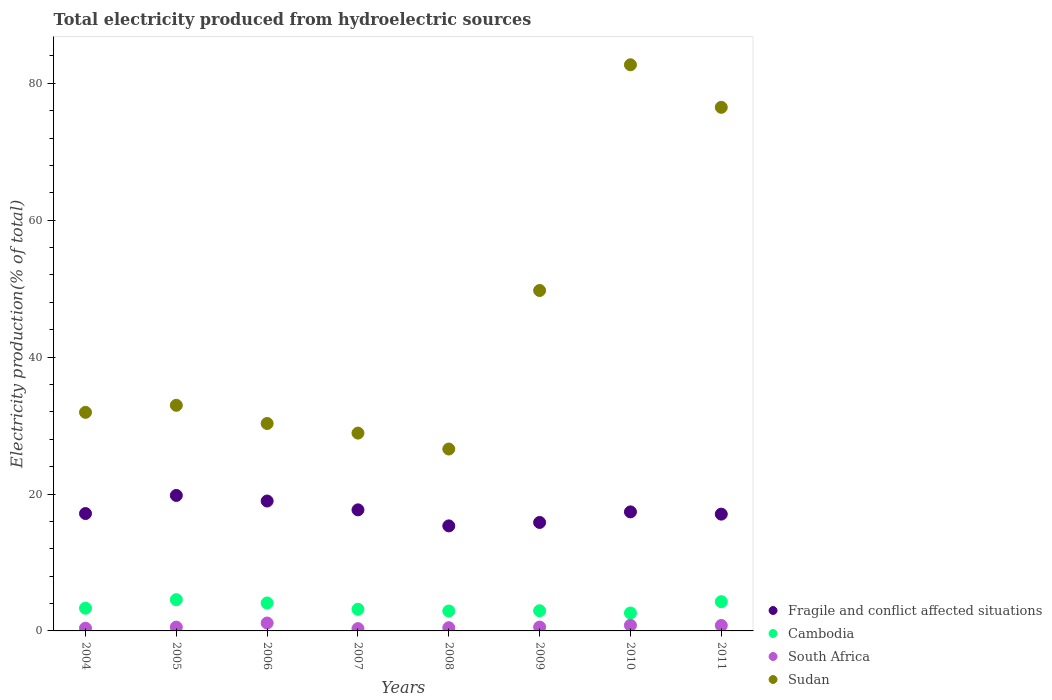What is the total electricity produced in Cambodia in 2005?
Provide a succinct answer. 4.56. Across all years, what is the maximum total electricity produced in Sudan?
Provide a succinct answer. 82.7. Across all years, what is the minimum total electricity produced in Fragile and conflict affected situations?
Your response must be concise. 15.34. In which year was the total electricity produced in Sudan minimum?
Your answer should be very brief. 2008. What is the total total electricity produced in South Africa in the graph?
Offer a very short reply. 5.09. What is the difference between the total electricity produced in Fragile and conflict affected situations in 2004 and that in 2006?
Provide a succinct answer. -1.83. What is the difference between the total electricity produced in Cambodia in 2004 and the total electricity produced in Sudan in 2007?
Offer a very short reply. -25.58. What is the average total electricity produced in South Africa per year?
Make the answer very short. 0.64. In the year 2011, what is the difference between the total electricity produced in Fragile and conflict affected situations and total electricity produced in Sudan?
Ensure brevity in your answer.  -59.43. In how many years, is the total electricity produced in Sudan greater than 60 %?
Ensure brevity in your answer.  2. What is the ratio of the total electricity produced in Cambodia in 2004 to that in 2007?
Your answer should be very brief. 1.05. What is the difference between the highest and the second highest total electricity produced in South Africa?
Give a very brief answer. 0.33. What is the difference between the highest and the lowest total electricity produced in Sudan?
Your answer should be very brief. 56.13. Is the sum of the total electricity produced in Cambodia in 2004 and 2007 greater than the maximum total electricity produced in Fragile and conflict affected situations across all years?
Give a very brief answer. No. Does the total electricity produced in Fragile and conflict affected situations monotonically increase over the years?
Give a very brief answer. No. Is the total electricity produced in Fragile and conflict affected situations strictly greater than the total electricity produced in Cambodia over the years?
Offer a terse response. Yes. What is the difference between two consecutive major ticks on the Y-axis?
Ensure brevity in your answer.  20. Does the graph contain any zero values?
Provide a short and direct response. No. Does the graph contain grids?
Keep it short and to the point. No. How are the legend labels stacked?
Ensure brevity in your answer.  Vertical. What is the title of the graph?
Provide a short and direct response. Total electricity produced from hydroelectric sources. Does "Solomon Islands" appear as one of the legend labels in the graph?
Give a very brief answer. No. What is the label or title of the X-axis?
Your answer should be very brief. Years. What is the label or title of the Y-axis?
Ensure brevity in your answer.  Electricity production(% of total). What is the Electricity production(% of total) in Fragile and conflict affected situations in 2004?
Make the answer very short. 17.15. What is the Electricity production(% of total) of Cambodia in 2004?
Give a very brief answer. 3.32. What is the Electricity production(% of total) of South Africa in 2004?
Give a very brief answer. 0.39. What is the Electricity production(% of total) of Sudan in 2004?
Provide a succinct answer. 31.93. What is the Electricity production(% of total) in Fragile and conflict affected situations in 2005?
Give a very brief answer. 19.79. What is the Electricity production(% of total) of Cambodia in 2005?
Offer a terse response. 4.56. What is the Electricity production(% of total) of South Africa in 2005?
Your answer should be very brief. 0.55. What is the Electricity production(% of total) in Sudan in 2005?
Provide a succinct answer. 32.96. What is the Electricity production(% of total) of Fragile and conflict affected situations in 2006?
Your answer should be very brief. 18.98. What is the Electricity production(% of total) in Cambodia in 2006?
Your response must be concise. 4.08. What is the Electricity production(% of total) of South Africa in 2006?
Give a very brief answer. 1.16. What is the Electricity production(% of total) in Sudan in 2006?
Your response must be concise. 30.3. What is the Electricity production(% of total) of Fragile and conflict affected situations in 2007?
Your response must be concise. 17.69. What is the Electricity production(% of total) in Cambodia in 2007?
Your answer should be very brief. 3.16. What is the Electricity production(% of total) of South Africa in 2007?
Offer a terse response. 0.33. What is the Electricity production(% of total) of Sudan in 2007?
Provide a succinct answer. 28.9. What is the Electricity production(% of total) of Fragile and conflict affected situations in 2008?
Your answer should be very brief. 15.34. What is the Electricity production(% of total) in Cambodia in 2008?
Ensure brevity in your answer.  2.91. What is the Electricity production(% of total) in South Africa in 2008?
Ensure brevity in your answer.  0.47. What is the Electricity production(% of total) of Sudan in 2008?
Ensure brevity in your answer.  26.57. What is the Electricity production(% of total) in Fragile and conflict affected situations in 2009?
Ensure brevity in your answer.  15.85. What is the Electricity production(% of total) in Cambodia in 2009?
Your answer should be very brief. 2.95. What is the Electricity production(% of total) of South Africa in 2009?
Your response must be concise. 0.57. What is the Electricity production(% of total) of Sudan in 2009?
Your answer should be very brief. 49.73. What is the Electricity production(% of total) of Fragile and conflict affected situations in 2010?
Give a very brief answer. 17.39. What is the Electricity production(% of total) in Cambodia in 2010?
Your answer should be compact. 2.62. What is the Electricity production(% of total) in South Africa in 2010?
Provide a short and direct response. 0.82. What is the Electricity production(% of total) in Sudan in 2010?
Provide a short and direct response. 82.7. What is the Electricity production(% of total) of Fragile and conflict affected situations in 2011?
Your answer should be very brief. 17.06. What is the Electricity production(% of total) of Cambodia in 2011?
Your answer should be very brief. 4.27. What is the Electricity production(% of total) of South Africa in 2011?
Offer a terse response. 0.79. What is the Electricity production(% of total) of Sudan in 2011?
Your answer should be very brief. 76.49. Across all years, what is the maximum Electricity production(% of total) in Fragile and conflict affected situations?
Your response must be concise. 19.79. Across all years, what is the maximum Electricity production(% of total) in Cambodia?
Offer a very short reply. 4.56. Across all years, what is the maximum Electricity production(% of total) of South Africa?
Offer a very short reply. 1.16. Across all years, what is the maximum Electricity production(% of total) of Sudan?
Give a very brief answer. 82.7. Across all years, what is the minimum Electricity production(% of total) in Fragile and conflict affected situations?
Your answer should be compact. 15.34. Across all years, what is the minimum Electricity production(% of total) of Cambodia?
Offer a very short reply. 2.62. Across all years, what is the minimum Electricity production(% of total) of South Africa?
Your answer should be compact. 0.33. Across all years, what is the minimum Electricity production(% of total) of Sudan?
Keep it short and to the point. 26.57. What is the total Electricity production(% of total) in Fragile and conflict affected situations in the graph?
Your answer should be compact. 139.24. What is the total Electricity production(% of total) in Cambodia in the graph?
Give a very brief answer. 27.86. What is the total Electricity production(% of total) of South Africa in the graph?
Provide a succinct answer. 5.09. What is the total Electricity production(% of total) in Sudan in the graph?
Offer a terse response. 359.58. What is the difference between the Electricity production(% of total) of Fragile and conflict affected situations in 2004 and that in 2005?
Provide a short and direct response. -2.64. What is the difference between the Electricity production(% of total) in Cambodia in 2004 and that in 2005?
Your answer should be compact. -1.25. What is the difference between the Electricity production(% of total) of South Africa in 2004 and that in 2005?
Offer a very short reply. -0.16. What is the difference between the Electricity production(% of total) in Sudan in 2004 and that in 2005?
Your answer should be very brief. -1.03. What is the difference between the Electricity production(% of total) in Fragile and conflict affected situations in 2004 and that in 2006?
Make the answer very short. -1.83. What is the difference between the Electricity production(% of total) in Cambodia in 2004 and that in 2006?
Provide a succinct answer. -0.76. What is the difference between the Electricity production(% of total) of South Africa in 2004 and that in 2006?
Make the answer very short. -0.76. What is the difference between the Electricity production(% of total) of Sudan in 2004 and that in 2006?
Offer a very short reply. 1.63. What is the difference between the Electricity production(% of total) of Fragile and conflict affected situations in 2004 and that in 2007?
Your answer should be compact. -0.54. What is the difference between the Electricity production(% of total) in Cambodia in 2004 and that in 2007?
Your response must be concise. 0.16. What is the difference between the Electricity production(% of total) in South Africa in 2004 and that in 2007?
Your answer should be very brief. 0.06. What is the difference between the Electricity production(% of total) in Sudan in 2004 and that in 2007?
Offer a very short reply. 3.03. What is the difference between the Electricity production(% of total) of Fragile and conflict affected situations in 2004 and that in 2008?
Provide a short and direct response. 1.8. What is the difference between the Electricity production(% of total) in Cambodia in 2004 and that in 2008?
Provide a short and direct response. 0.41. What is the difference between the Electricity production(% of total) of South Africa in 2004 and that in 2008?
Ensure brevity in your answer.  -0.08. What is the difference between the Electricity production(% of total) of Sudan in 2004 and that in 2008?
Give a very brief answer. 5.36. What is the difference between the Electricity production(% of total) in Fragile and conflict affected situations in 2004 and that in 2009?
Keep it short and to the point. 1.3. What is the difference between the Electricity production(% of total) in Cambodia in 2004 and that in 2009?
Your response must be concise. 0.37. What is the difference between the Electricity production(% of total) in South Africa in 2004 and that in 2009?
Offer a terse response. -0.17. What is the difference between the Electricity production(% of total) of Sudan in 2004 and that in 2009?
Give a very brief answer. -17.8. What is the difference between the Electricity production(% of total) of Fragile and conflict affected situations in 2004 and that in 2010?
Make the answer very short. -0.24. What is the difference between the Electricity production(% of total) in Cambodia in 2004 and that in 2010?
Keep it short and to the point. 0.7. What is the difference between the Electricity production(% of total) of South Africa in 2004 and that in 2010?
Keep it short and to the point. -0.43. What is the difference between the Electricity production(% of total) of Sudan in 2004 and that in 2010?
Keep it short and to the point. -50.77. What is the difference between the Electricity production(% of total) of Fragile and conflict affected situations in 2004 and that in 2011?
Offer a very short reply. 0.09. What is the difference between the Electricity production(% of total) in Cambodia in 2004 and that in 2011?
Your response must be concise. -0.96. What is the difference between the Electricity production(% of total) of South Africa in 2004 and that in 2011?
Provide a short and direct response. -0.4. What is the difference between the Electricity production(% of total) in Sudan in 2004 and that in 2011?
Your answer should be very brief. -44.56. What is the difference between the Electricity production(% of total) of Fragile and conflict affected situations in 2005 and that in 2006?
Your answer should be very brief. 0.82. What is the difference between the Electricity production(% of total) in Cambodia in 2005 and that in 2006?
Give a very brief answer. 0.48. What is the difference between the Electricity production(% of total) of South Africa in 2005 and that in 2006?
Your answer should be compact. -0.6. What is the difference between the Electricity production(% of total) of Sudan in 2005 and that in 2006?
Give a very brief answer. 2.66. What is the difference between the Electricity production(% of total) in Fragile and conflict affected situations in 2005 and that in 2007?
Offer a terse response. 2.11. What is the difference between the Electricity production(% of total) of Cambodia in 2005 and that in 2007?
Offer a very short reply. 1.41. What is the difference between the Electricity production(% of total) of South Africa in 2005 and that in 2007?
Your response must be concise. 0.22. What is the difference between the Electricity production(% of total) in Sudan in 2005 and that in 2007?
Your answer should be compact. 4.06. What is the difference between the Electricity production(% of total) of Fragile and conflict affected situations in 2005 and that in 2008?
Offer a very short reply. 4.45. What is the difference between the Electricity production(% of total) of Cambodia in 2005 and that in 2008?
Provide a succinct answer. 1.66. What is the difference between the Electricity production(% of total) in South Africa in 2005 and that in 2008?
Provide a short and direct response. 0.08. What is the difference between the Electricity production(% of total) in Sudan in 2005 and that in 2008?
Make the answer very short. 6.39. What is the difference between the Electricity production(% of total) of Fragile and conflict affected situations in 2005 and that in 2009?
Offer a terse response. 3.95. What is the difference between the Electricity production(% of total) of Cambodia in 2005 and that in 2009?
Ensure brevity in your answer.  1.62. What is the difference between the Electricity production(% of total) of South Africa in 2005 and that in 2009?
Provide a short and direct response. -0.02. What is the difference between the Electricity production(% of total) of Sudan in 2005 and that in 2009?
Your response must be concise. -16.77. What is the difference between the Electricity production(% of total) in Fragile and conflict affected situations in 2005 and that in 2010?
Your answer should be very brief. 2.4. What is the difference between the Electricity production(% of total) of Cambodia in 2005 and that in 2010?
Ensure brevity in your answer.  1.95. What is the difference between the Electricity production(% of total) of South Africa in 2005 and that in 2010?
Your answer should be compact. -0.27. What is the difference between the Electricity production(% of total) of Sudan in 2005 and that in 2010?
Offer a terse response. -49.75. What is the difference between the Electricity production(% of total) in Fragile and conflict affected situations in 2005 and that in 2011?
Offer a terse response. 2.73. What is the difference between the Electricity production(% of total) in Cambodia in 2005 and that in 2011?
Give a very brief answer. 0.29. What is the difference between the Electricity production(% of total) in South Africa in 2005 and that in 2011?
Ensure brevity in your answer.  -0.24. What is the difference between the Electricity production(% of total) in Sudan in 2005 and that in 2011?
Offer a very short reply. -43.53. What is the difference between the Electricity production(% of total) of Fragile and conflict affected situations in 2006 and that in 2007?
Keep it short and to the point. 1.29. What is the difference between the Electricity production(% of total) in Cambodia in 2006 and that in 2007?
Provide a short and direct response. 0.93. What is the difference between the Electricity production(% of total) of South Africa in 2006 and that in 2007?
Make the answer very short. 0.82. What is the difference between the Electricity production(% of total) in Sudan in 2006 and that in 2007?
Provide a succinct answer. 1.4. What is the difference between the Electricity production(% of total) of Fragile and conflict affected situations in 2006 and that in 2008?
Keep it short and to the point. 3.63. What is the difference between the Electricity production(% of total) of Cambodia in 2006 and that in 2008?
Provide a short and direct response. 1.17. What is the difference between the Electricity production(% of total) in South Africa in 2006 and that in 2008?
Provide a succinct answer. 0.68. What is the difference between the Electricity production(% of total) in Sudan in 2006 and that in 2008?
Your answer should be very brief. 3.73. What is the difference between the Electricity production(% of total) of Fragile and conflict affected situations in 2006 and that in 2009?
Offer a very short reply. 3.13. What is the difference between the Electricity production(% of total) in Cambodia in 2006 and that in 2009?
Your response must be concise. 1.14. What is the difference between the Electricity production(% of total) of South Africa in 2006 and that in 2009?
Provide a succinct answer. 0.59. What is the difference between the Electricity production(% of total) in Sudan in 2006 and that in 2009?
Keep it short and to the point. -19.43. What is the difference between the Electricity production(% of total) of Fragile and conflict affected situations in 2006 and that in 2010?
Your answer should be compact. 1.59. What is the difference between the Electricity production(% of total) of Cambodia in 2006 and that in 2010?
Keep it short and to the point. 1.47. What is the difference between the Electricity production(% of total) of South Africa in 2006 and that in 2010?
Your answer should be very brief. 0.33. What is the difference between the Electricity production(% of total) in Sudan in 2006 and that in 2010?
Ensure brevity in your answer.  -52.4. What is the difference between the Electricity production(% of total) in Fragile and conflict affected situations in 2006 and that in 2011?
Provide a succinct answer. 1.92. What is the difference between the Electricity production(% of total) of Cambodia in 2006 and that in 2011?
Your response must be concise. -0.19. What is the difference between the Electricity production(% of total) in South Africa in 2006 and that in 2011?
Provide a short and direct response. 0.36. What is the difference between the Electricity production(% of total) of Sudan in 2006 and that in 2011?
Your answer should be compact. -46.18. What is the difference between the Electricity production(% of total) of Fragile and conflict affected situations in 2007 and that in 2008?
Keep it short and to the point. 2.34. What is the difference between the Electricity production(% of total) in Cambodia in 2007 and that in 2008?
Your answer should be compact. 0.25. What is the difference between the Electricity production(% of total) in South Africa in 2007 and that in 2008?
Offer a very short reply. -0.14. What is the difference between the Electricity production(% of total) of Sudan in 2007 and that in 2008?
Your response must be concise. 2.33. What is the difference between the Electricity production(% of total) in Fragile and conflict affected situations in 2007 and that in 2009?
Make the answer very short. 1.84. What is the difference between the Electricity production(% of total) of Cambodia in 2007 and that in 2009?
Ensure brevity in your answer.  0.21. What is the difference between the Electricity production(% of total) in South Africa in 2007 and that in 2009?
Your response must be concise. -0.23. What is the difference between the Electricity production(% of total) in Sudan in 2007 and that in 2009?
Your answer should be very brief. -20.83. What is the difference between the Electricity production(% of total) in Fragile and conflict affected situations in 2007 and that in 2010?
Provide a short and direct response. 0.3. What is the difference between the Electricity production(% of total) in Cambodia in 2007 and that in 2010?
Provide a short and direct response. 0.54. What is the difference between the Electricity production(% of total) of South Africa in 2007 and that in 2010?
Your answer should be very brief. -0.49. What is the difference between the Electricity production(% of total) in Sudan in 2007 and that in 2010?
Ensure brevity in your answer.  -53.81. What is the difference between the Electricity production(% of total) of Cambodia in 2007 and that in 2011?
Your answer should be very brief. -1.12. What is the difference between the Electricity production(% of total) in South Africa in 2007 and that in 2011?
Keep it short and to the point. -0.46. What is the difference between the Electricity production(% of total) in Sudan in 2007 and that in 2011?
Your answer should be very brief. -47.59. What is the difference between the Electricity production(% of total) of Fragile and conflict affected situations in 2008 and that in 2009?
Provide a short and direct response. -0.5. What is the difference between the Electricity production(% of total) in Cambodia in 2008 and that in 2009?
Your answer should be very brief. -0.04. What is the difference between the Electricity production(% of total) of South Africa in 2008 and that in 2009?
Provide a succinct answer. -0.1. What is the difference between the Electricity production(% of total) in Sudan in 2008 and that in 2009?
Provide a succinct answer. -23.16. What is the difference between the Electricity production(% of total) in Fragile and conflict affected situations in 2008 and that in 2010?
Provide a succinct answer. -2.04. What is the difference between the Electricity production(% of total) of Cambodia in 2008 and that in 2010?
Keep it short and to the point. 0.29. What is the difference between the Electricity production(% of total) of South Africa in 2008 and that in 2010?
Offer a very short reply. -0.35. What is the difference between the Electricity production(% of total) of Sudan in 2008 and that in 2010?
Your answer should be very brief. -56.13. What is the difference between the Electricity production(% of total) in Fragile and conflict affected situations in 2008 and that in 2011?
Your response must be concise. -1.72. What is the difference between the Electricity production(% of total) of Cambodia in 2008 and that in 2011?
Your answer should be compact. -1.37. What is the difference between the Electricity production(% of total) of South Africa in 2008 and that in 2011?
Offer a terse response. -0.32. What is the difference between the Electricity production(% of total) of Sudan in 2008 and that in 2011?
Provide a succinct answer. -49.92. What is the difference between the Electricity production(% of total) in Fragile and conflict affected situations in 2009 and that in 2010?
Ensure brevity in your answer.  -1.54. What is the difference between the Electricity production(% of total) in Cambodia in 2009 and that in 2010?
Offer a terse response. 0.33. What is the difference between the Electricity production(% of total) of South Africa in 2009 and that in 2010?
Offer a terse response. -0.26. What is the difference between the Electricity production(% of total) of Sudan in 2009 and that in 2010?
Make the answer very short. -32.97. What is the difference between the Electricity production(% of total) of Fragile and conflict affected situations in 2009 and that in 2011?
Provide a succinct answer. -1.22. What is the difference between the Electricity production(% of total) in Cambodia in 2009 and that in 2011?
Offer a very short reply. -1.33. What is the difference between the Electricity production(% of total) of South Africa in 2009 and that in 2011?
Your answer should be compact. -0.23. What is the difference between the Electricity production(% of total) of Sudan in 2009 and that in 2011?
Provide a short and direct response. -26.76. What is the difference between the Electricity production(% of total) of Fragile and conflict affected situations in 2010 and that in 2011?
Offer a terse response. 0.33. What is the difference between the Electricity production(% of total) in Cambodia in 2010 and that in 2011?
Provide a succinct answer. -1.66. What is the difference between the Electricity production(% of total) in South Africa in 2010 and that in 2011?
Your answer should be compact. 0.03. What is the difference between the Electricity production(% of total) of Sudan in 2010 and that in 2011?
Make the answer very short. 6.22. What is the difference between the Electricity production(% of total) of Fragile and conflict affected situations in 2004 and the Electricity production(% of total) of Cambodia in 2005?
Ensure brevity in your answer.  12.58. What is the difference between the Electricity production(% of total) in Fragile and conflict affected situations in 2004 and the Electricity production(% of total) in South Africa in 2005?
Provide a short and direct response. 16.6. What is the difference between the Electricity production(% of total) in Fragile and conflict affected situations in 2004 and the Electricity production(% of total) in Sudan in 2005?
Ensure brevity in your answer.  -15.81. What is the difference between the Electricity production(% of total) in Cambodia in 2004 and the Electricity production(% of total) in South Africa in 2005?
Provide a short and direct response. 2.77. What is the difference between the Electricity production(% of total) of Cambodia in 2004 and the Electricity production(% of total) of Sudan in 2005?
Your answer should be compact. -29.64. What is the difference between the Electricity production(% of total) of South Africa in 2004 and the Electricity production(% of total) of Sudan in 2005?
Offer a terse response. -32.56. What is the difference between the Electricity production(% of total) in Fragile and conflict affected situations in 2004 and the Electricity production(% of total) in Cambodia in 2006?
Offer a very short reply. 13.07. What is the difference between the Electricity production(% of total) in Fragile and conflict affected situations in 2004 and the Electricity production(% of total) in South Africa in 2006?
Your answer should be compact. 15.99. What is the difference between the Electricity production(% of total) in Fragile and conflict affected situations in 2004 and the Electricity production(% of total) in Sudan in 2006?
Provide a succinct answer. -13.16. What is the difference between the Electricity production(% of total) in Cambodia in 2004 and the Electricity production(% of total) in South Africa in 2006?
Keep it short and to the point. 2.16. What is the difference between the Electricity production(% of total) of Cambodia in 2004 and the Electricity production(% of total) of Sudan in 2006?
Ensure brevity in your answer.  -26.99. What is the difference between the Electricity production(% of total) of South Africa in 2004 and the Electricity production(% of total) of Sudan in 2006?
Offer a terse response. -29.91. What is the difference between the Electricity production(% of total) of Fragile and conflict affected situations in 2004 and the Electricity production(% of total) of Cambodia in 2007?
Keep it short and to the point. 13.99. What is the difference between the Electricity production(% of total) of Fragile and conflict affected situations in 2004 and the Electricity production(% of total) of South Africa in 2007?
Provide a short and direct response. 16.81. What is the difference between the Electricity production(% of total) of Fragile and conflict affected situations in 2004 and the Electricity production(% of total) of Sudan in 2007?
Keep it short and to the point. -11.75. What is the difference between the Electricity production(% of total) of Cambodia in 2004 and the Electricity production(% of total) of South Africa in 2007?
Give a very brief answer. 2.98. What is the difference between the Electricity production(% of total) of Cambodia in 2004 and the Electricity production(% of total) of Sudan in 2007?
Give a very brief answer. -25.58. What is the difference between the Electricity production(% of total) in South Africa in 2004 and the Electricity production(% of total) in Sudan in 2007?
Keep it short and to the point. -28.5. What is the difference between the Electricity production(% of total) in Fragile and conflict affected situations in 2004 and the Electricity production(% of total) in Cambodia in 2008?
Your response must be concise. 14.24. What is the difference between the Electricity production(% of total) in Fragile and conflict affected situations in 2004 and the Electricity production(% of total) in South Africa in 2008?
Your response must be concise. 16.68. What is the difference between the Electricity production(% of total) of Fragile and conflict affected situations in 2004 and the Electricity production(% of total) of Sudan in 2008?
Your answer should be compact. -9.42. What is the difference between the Electricity production(% of total) in Cambodia in 2004 and the Electricity production(% of total) in South Africa in 2008?
Provide a short and direct response. 2.85. What is the difference between the Electricity production(% of total) in Cambodia in 2004 and the Electricity production(% of total) in Sudan in 2008?
Your answer should be compact. -23.25. What is the difference between the Electricity production(% of total) in South Africa in 2004 and the Electricity production(% of total) in Sudan in 2008?
Keep it short and to the point. -26.18. What is the difference between the Electricity production(% of total) in Fragile and conflict affected situations in 2004 and the Electricity production(% of total) in Cambodia in 2009?
Offer a very short reply. 14.2. What is the difference between the Electricity production(% of total) in Fragile and conflict affected situations in 2004 and the Electricity production(% of total) in South Africa in 2009?
Offer a terse response. 16.58. What is the difference between the Electricity production(% of total) in Fragile and conflict affected situations in 2004 and the Electricity production(% of total) in Sudan in 2009?
Make the answer very short. -32.58. What is the difference between the Electricity production(% of total) of Cambodia in 2004 and the Electricity production(% of total) of South Africa in 2009?
Provide a short and direct response. 2.75. What is the difference between the Electricity production(% of total) of Cambodia in 2004 and the Electricity production(% of total) of Sudan in 2009?
Ensure brevity in your answer.  -46.41. What is the difference between the Electricity production(% of total) in South Africa in 2004 and the Electricity production(% of total) in Sudan in 2009?
Keep it short and to the point. -49.34. What is the difference between the Electricity production(% of total) of Fragile and conflict affected situations in 2004 and the Electricity production(% of total) of Cambodia in 2010?
Ensure brevity in your answer.  14.53. What is the difference between the Electricity production(% of total) in Fragile and conflict affected situations in 2004 and the Electricity production(% of total) in South Africa in 2010?
Offer a terse response. 16.32. What is the difference between the Electricity production(% of total) of Fragile and conflict affected situations in 2004 and the Electricity production(% of total) of Sudan in 2010?
Provide a succinct answer. -65.56. What is the difference between the Electricity production(% of total) in Cambodia in 2004 and the Electricity production(% of total) in South Africa in 2010?
Give a very brief answer. 2.49. What is the difference between the Electricity production(% of total) of Cambodia in 2004 and the Electricity production(% of total) of Sudan in 2010?
Keep it short and to the point. -79.39. What is the difference between the Electricity production(% of total) in South Africa in 2004 and the Electricity production(% of total) in Sudan in 2010?
Offer a terse response. -82.31. What is the difference between the Electricity production(% of total) of Fragile and conflict affected situations in 2004 and the Electricity production(% of total) of Cambodia in 2011?
Offer a very short reply. 12.87. What is the difference between the Electricity production(% of total) of Fragile and conflict affected situations in 2004 and the Electricity production(% of total) of South Africa in 2011?
Provide a succinct answer. 16.36. What is the difference between the Electricity production(% of total) in Fragile and conflict affected situations in 2004 and the Electricity production(% of total) in Sudan in 2011?
Offer a terse response. -59.34. What is the difference between the Electricity production(% of total) in Cambodia in 2004 and the Electricity production(% of total) in South Africa in 2011?
Keep it short and to the point. 2.52. What is the difference between the Electricity production(% of total) of Cambodia in 2004 and the Electricity production(% of total) of Sudan in 2011?
Keep it short and to the point. -73.17. What is the difference between the Electricity production(% of total) of South Africa in 2004 and the Electricity production(% of total) of Sudan in 2011?
Give a very brief answer. -76.09. What is the difference between the Electricity production(% of total) of Fragile and conflict affected situations in 2005 and the Electricity production(% of total) of Cambodia in 2006?
Give a very brief answer. 15.71. What is the difference between the Electricity production(% of total) of Fragile and conflict affected situations in 2005 and the Electricity production(% of total) of South Africa in 2006?
Your response must be concise. 18.64. What is the difference between the Electricity production(% of total) in Fragile and conflict affected situations in 2005 and the Electricity production(% of total) in Sudan in 2006?
Provide a short and direct response. -10.51. What is the difference between the Electricity production(% of total) of Cambodia in 2005 and the Electricity production(% of total) of South Africa in 2006?
Provide a short and direct response. 3.41. What is the difference between the Electricity production(% of total) in Cambodia in 2005 and the Electricity production(% of total) in Sudan in 2006?
Your answer should be very brief. -25.74. What is the difference between the Electricity production(% of total) of South Africa in 2005 and the Electricity production(% of total) of Sudan in 2006?
Provide a short and direct response. -29.75. What is the difference between the Electricity production(% of total) in Fragile and conflict affected situations in 2005 and the Electricity production(% of total) in Cambodia in 2007?
Your response must be concise. 16.63. What is the difference between the Electricity production(% of total) in Fragile and conflict affected situations in 2005 and the Electricity production(% of total) in South Africa in 2007?
Provide a short and direct response. 19.46. What is the difference between the Electricity production(% of total) in Fragile and conflict affected situations in 2005 and the Electricity production(% of total) in Sudan in 2007?
Provide a succinct answer. -9.11. What is the difference between the Electricity production(% of total) of Cambodia in 2005 and the Electricity production(% of total) of South Africa in 2007?
Provide a succinct answer. 4.23. What is the difference between the Electricity production(% of total) in Cambodia in 2005 and the Electricity production(% of total) in Sudan in 2007?
Offer a very short reply. -24.33. What is the difference between the Electricity production(% of total) of South Africa in 2005 and the Electricity production(% of total) of Sudan in 2007?
Your response must be concise. -28.35. What is the difference between the Electricity production(% of total) in Fragile and conflict affected situations in 2005 and the Electricity production(% of total) in Cambodia in 2008?
Keep it short and to the point. 16.88. What is the difference between the Electricity production(% of total) in Fragile and conflict affected situations in 2005 and the Electricity production(% of total) in South Africa in 2008?
Ensure brevity in your answer.  19.32. What is the difference between the Electricity production(% of total) in Fragile and conflict affected situations in 2005 and the Electricity production(% of total) in Sudan in 2008?
Provide a succinct answer. -6.78. What is the difference between the Electricity production(% of total) in Cambodia in 2005 and the Electricity production(% of total) in South Africa in 2008?
Give a very brief answer. 4.09. What is the difference between the Electricity production(% of total) in Cambodia in 2005 and the Electricity production(% of total) in Sudan in 2008?
Ensure brevity in your answer.  -22.01. What is the difference between the Electricity production(% of total) in South Africa in 2005 and the Electricity production(% of total) in Sudan in 2008?
Your answer should be compact. -26.02. What is the difference between the Electricity production(% of total) of Fragile and conflict affected situations in 2005 and the Electricity production(% of total) of Cambodia in 2009?
Offer a very short reply. 16.85. What is the difference between the Electricity production(% of total) of Fragile and conflict affected situations in 2005 and the Electricity production(% of total) of South Africa in 2009?
Make the answer very short. 19.22. What is the difference between the Electricity production(% of total) of Fragile and conflict affected situations in 2005 and the Electricity production(% of total) of Sudan in 2009?
Offer a very short reply. -29.94. What is the difference between the Electricity production(% of total) of Cambodia in 2005 and the Electricity production(% of total) of South Africa in 2009?
Ensure brevity in your answer.  4. What is the difference between the Electricity production(% of total) in Cambodia in 2005 and the Electricity production(% of total) in Sudan in 2009?
Provide a succinct answer. -45.17. What is the difference between the Electricity production(% of total) of South Africa in 2005 and the Electricity production(% of total) of Sudan in 2009?
Provide a succinct answer. -49.18. What is the difference between the Electricity production(% of total) in Fragile and conflict affected situations in 2005 and the Electricity production(% of total) in Cambodia in 2010?
Offer a terse response. 17.18. What is the difference between the Electricity production(% of total) in Fragile and conflict affected situations in 2005 and the Electricity production(% of total) in South Africa in 2010?
Your answer should be very brief. 18.97. What is the difference between the Electricity production(% of total) in Fragile and conflict affected situations in 2005 and the Electricity production(% of total) in Sudan in 2010?
Provide a short and direct response. -62.91. What is the difference between the Electricity production(% of total) in Cambodia in 2005 and the Electricity production(% of total) in South Africa in 2010?
Offer a terse response. 3.74. What is the difference between the Electricity production(% of total) of Cambodia in 2005 and the Electricity production(% of total) of Sudan in 2010?
Your answer should be very brief. -78.14. What is the difference between the Electricity production(% of total) of South Africa in 2005 and the Electricity production(% of total) of Sudan in 2010?
Provide a short and direct response. -82.15. What is the difference between the Electricity production(% of total) in Fragile and conflict affected situations in 2005 and the Electricity production(% of total) in Cambodia in 2011?
Provide a succinct answer. 15.52. What is the difference between the Electricity production(% of total) of Fragile and conflict affected situations in 2005 and the Electricity production(% of total) of South Africa in 2011?
Provide a short and direct response. 19. What is the difference between the Electricity production(% of total) in Fragile and conflict affected situations in 2005 and the Electricity production(% of total) in Sudan in 2011?
Provide a short and direct response. -56.7. What is the difference between the Electricity production(% of total) in Cambodia in 2005 and the Electricity production(% of total) in South Africa in 2011?
Offer a terse response. 3.77. What is the difference between the Electricity production(% of total) of Cambodia in 2005 and the Electricity production(% of total) of Sudan in 2011?
Your answer should be very brief. -71.92. What is the difference between the Electricity production(% of total) in South Africa in 2005 and the Electricity production(% of total) in Sudan in 2011?
Offer a terse response. -75.94. What is the difference between the Electricity production(% of total) in Fragile and conflict affected situations in 2006 and the Electricity production(% of total) in Cambodia in 2007?
Offer a very short reply. 15.82. What is the difference between the Electricity production(% of total) in Fragile and conflict affected situations in 2006 and the Electricity production(% of total) in South Africa in 2007?
Offer a terse response. 18.64. What is the difference between the Electricity production(% of total) of Fragile and conflict affected situations in 2006 and the Electricity production(% of total) of Sudan in 2007?
Offer a terse response. -9.92. What is the difference between the Electricity production(% of total) of Cambodia in 2006 and the Electricity production(% of total) of South Africa in 2007?
Your answer should be very brief. 3.75. What is the difference between the Electricity production(% of total) in Cambodia in 2006 and the Electricity production(% of total) in Sudan in 2007?
Provide a short and direct response. -24.82. What is the difference between the Electricity production(% of total) in South Africa in 2006 and the Electricity production(% of total) in Sudan in 2007?
Keep it short and to the point. -27.74. What is the difference between the Electricity production(% of total) of Fragile and conflict affected situations in 2006 and the Electricity production(% of total) of Cambodia in 2008?
Ensure brevity in your answer.  16.07. What is the difference between the Electricity production(% of total) of Fragile and conflict affected situations in 2006 and the Electricity production(% of total) of South Africa in 2008?
Keep it short and to the point. 18.51. What is the difference between the Electricity production(% of total) in Fragile and conflict affected situations in 2006 and the Electricity production(% of total) in Sudan in 2008?
Offer a very short reply. -7.6. What is the difference between the Electricity production(% of total) of Cambodia in 2006 and the Electricity production(% of total) of South Africa in 2008?
Provide a short and direct response. 3.61. What is the difference between the Electricity production(% of total) in Cambodia in 2006 and the Electricity production(% of total) in Sudan in 2008?
Offer a very short reply. -22.49. What is the difference between the Electricity production(% of total) in South Africa in 2006 and the Electricity production(% of total) in Sudan in 2008?
Give a very brief answer. -25.42. What is the difference between the Electricity production(% of total) in Fragile and conflict affected situations in 2006 and the Electricity production(% of total) in Cambodia in 2009?
Offer a terse response. 16.03. What is the difference between the Electricity production(% of total) of Fragile and conflict affected situations in 2006 and the Electricity production(% of total) of South Africa in 2009?
Your answer should be compact. 18.41. What is the difference between the Electricity production(% of total) of Fragile and conflict affected situations in 2006 and the Electricity production(% of total) of Sudan in 2009?
Provide a succinct answer. -30.75. What is the difference between the Electricity production(% of total) of Cambodia in 2006 and the Electricity production(% of total) of South Africa in 2009?
Your answer should be very brief. 3.51. What is the difference between the Electricity production(% of total) in Cambodia in 2006 and the Electricity production(% of total) in Sudan in 2009?
Your answer should be compact. -45.65. What is the difference between the Electricity production(% of total) of South Africa in 2006 and the Electricity production(% of total) of Sudan in 2009?
Your response must be concise. -48.58. What is the difference between the Electricity production(% of total) of Fragile and conflict affected situations in 2006 and the Electricity production(% of total) of Cambodia in 2010?
Offer a very short reply. 16.36. What is the difference between the Electricity production(% of total) in Fragile and conflict affected situations in 2006 and the Electricity production(% of total) in South Africa in 2010?
Your answer should be very brief. 18.15. What is the difference between the Electricity production(% of total) of Fragile and conflict affected situations in 2006 and the Electricity production(% of total) of Sudan in 2010?
Ensure brevity in your answer.  -63.73. What is the difference between the Electricity production(% of total) of Cambodia in 2006 and the Electricity production(% of total) of South Africa in 2010?
Offer a very short reply. 3.26. What is the difference between the Electricity production(% of total) of Cambodia in 2006 and the Electricity production(% of total) of Sudan in 2010?
Offer a terse response. -78.62. What is the difference between the Electricity production(% of total) in South Africa in 2006 and the Electricity production(% of total) in Sudan in 2010?
Provide a short and direct response. -81.55. What is the difference between the Electricity production(% of total) of Fragile and conflict affected situations in 2006 and the Electricity production(% of total) of Cambodia in 2011?
Offer a terse response. 14.7. What is the difference between the Electricity production(% of total) in Fragile and conflict affected situations in 2006 and the Electricity production(% of total) in South Africa in 2011?
Provide a short and direct response. 18.18. What is the difference between the Electricity production(% of total) in Fragile and conflict affected situations in 2006 and the Electricity production(% of total) in Sudan in 2011?
Keep it short and to the point. -57.51. What is the difference between the Electricity production(% of total) in Cambodia in 2006 and the Electricity production(% of total) in South Africa in 2011?
Provide a short and direct response. 3.29. What is the difference between the Electricity production(% of total) in Cambodia in 2006 and the Electricity production(% of total) in Sudan in 2011?
Your response must be concise. -72.41. What is the difference between the Electricity production(% of total) in South Africa in 2006 and the Electricity production(% of total) in Sudan in 2011?
Provide a short and direct response. -75.33. What is the difference between the Electricity production(% of total) of Fragile and conflict affected situations in 2007 and the Electricity production(% of total) of Cambodia in 2008?
Offer a very short reply. 14.78. What is the difference between the Electricity production(% of total) of Fragile and conflict affected situations in 2007 and the Electricity production(% of total) of South Africa in 2008?
Give a very brief answer. 17.22. What is the difference between the Electricity production(% of total) in Fragile and conflict affected situations in 2007 and the Electricity production(% of total) in Sudan in 2008?
Offer a terse response. -8.89. What is the difference between the Electricity production(% of total) of Cambodia in 2007 and the Electricity production(% of total) of South Africa in 2008?
Keep it short and to the point. 2.69. What is the difference between the Electricity production(% of total) of Cambodia in 2007 and the Electricity production(% of total) of Sudan in 2008?
Give a very brief answer. -23.41. What is the difference between the Electricity production(% of total) in South Africa in 2007 and the Electricity production(% of total) in Sudan in 2008?
Provide a succinct answer. -26.24. What is the difference between the Electricity production(% of total) of Fragile and conflict affected situations in 2007 and the Electricity production(% of total) of Cambodia in 2009?
Offer a very short reply. 14.74. What is the difference between the Electricity production(% of total) in Fragile and conflict affected situations in 2007 and the Electricity production(% of total) in South Africa in 2009?
Your response must be concise. 17.12. What is the difference between the Electricity production(% of total) of Fragile and conflict affected situations in 2007 and the Electricity production(% of total) of Sudan in 2009?
Offer a very short reply. -32.04. What is the difference between the Electricity production(% of total) of Cambodia in 2007 and the Electricity production(% of total) of South Africa in 2009?
Offer a terse response. 2.59. What is the difference between the Electricity production(% of total) in Cambodia in 2007 and the Electricity production(% of total) in Sudan in 2009?
Offer a terse response. -46.57. What is the difference between the Electricity production(% of total) of South Africa in 2007 and the Electricity production(% of total) of Sudan in 2009?
Your response must be concise. -49.4. What is the difference between the Electricity production(% of total) in Fragile and conflict affected situations in 2007 and the Electricity production(% of total) in Cambodia in 2010?
Provide a succinct answer. 15.07. What is the difference between the Electricity production(% of total) of Fragile and conflict affected situations in 2007 and the Electricity production(% of total) of South Africa in 2010?
Offer a very short reply. 16.86. What is the difference between the Electricity production(% of total) in Fragile and conflict affected situations in 2007 and the Electricity production(% of total) in Sudan in 2010?
Give a very brief answer. -65.02. What is the difference between the Electricity production(% of total) of Cambodia in 2007 and the Electricity production(% of total) of South Africa in 2010?
Your answer should be compact. 2.33. What is the difference between the Electricity production(% of total) of Cambodia in 2007 and the Electricity production(% of total) of Sudan in 2010?
Ensure brevity in your answer.  -79.55. What is the difference between the Electricity production(% of total) of South Africa in 2007 and the Electricity production(% of total) of Sudan in 2010?
Provide a succinct answer. -82.37. What is the difference between the Electricity production(% of total) in Fragile and conflict affected situations in 2007 and the Electricity production(% of total) in Cambodia in 2011?
Offer a terse response. 13.41. What is the difference between the Electricity production(% of total) in Fragile and conflict affected situations in 2007 and the Electricity production(% of total) in South Africa in 2011?
Make the answer very short. 16.89. What is the difference between the Electricity production(% of total) of Fragile and conflict affected situations in 2007 and the Electricity production(% of total) of Sudan in 2011?
Offer a terse response. -58.8. What is the difference between the Electricity production(% of total) in Cambodia in 2007 and the Electricity production(% of total) in South Africa in 2011?
Offer a very short reply. 2.36. What is the difference between the Electricity production(% of total) of Cambodia in 2007 and the Electricity production(% of total) of Sudan in 2011?
Give a very brief answer. -73.33. What is the difference between the Electricity production(% of total) in South Africa in 2007 and the Electricity production(% of total) in Sudan in 2011?
Keep it short and to the point. -76.15. What is the difference between the Electricity production(% of total) of Fragile and conflict affected situations in 2008 and the Electricity production(% of total) of Cambodia in 2009?
Provide a short and direct response. 12.4. What is the difference between the Electricity production(% of total) of Fragile and conflict affected situations in 2008 and the Electricity production(% of total) of South Africa in 2009?
Ensure brevity in your answer.  14.78. What is the difference between the Electricity production(% of total) of Fragile and conflict affected situations in 2008 and the Electricity production(% of total) of Sudan in 2009?
Provide a short and direct response. -34.39. What is the difference between the Electricity production(% of total) in Cambodia in 2008 and the Electricity production(% of total) in South Africa in 2009?
Offer a terse response. 2.34. What is the difference between the Electricity production(% of total) of Cambodia in 2008 and the Electricity production(% of total) of Sudan in 2009?
Ensure brevity in your answer.  -46.82. What is the difference between the Electricity production(% of total) of South Africa in 2008 and the Electricity production(% of total) of Sudan in 2009?
Provide a succinct answer. -49.26. What is the difference between the Electricity production(% of total) in Fragile and conflict affected situations in 2008 and the Electricity production(% of total) in Cambodia in 2010?
Provide a succinct answer. 12.73. What is the difference between the Electricity production(% of total) of Fragile and conflict affected situations in 2008 and the Electricity production(% of total) of South Africa in 2010?
Your response must be concise. 14.52. What is the difference between the Electricity production(% of total) of Fragile and conflict affected situations in 2008 and the Electricity production(% of total) of Sudan in 2010?
Make the answer very short. -67.36. What is the difference between the Electricity production(% of total) of Cambodia in 2008 and the Electricity production(% of total) of South Africa in 2010?
Provide a short and direct response. 2.08. What is the difference between the Electricity production(% of total) in Cambodia in 2008 and the Electricity production(% of total) in Sudan in 2010?
Give a very brief answer. -79.8. What is the difference between the Electricity production(% of total) in South Africa in 2008 and the Electricity production(% of total) in Sudan in 2010?
Offer a terse response. -82.23. What is the difference between the Electricity production(% of total) in Fragile and conflict affected situations in 2008 and the Electricity production(% of total) in Cambodia in 2011?
Make the answer very short. 11.07. What is the difference between the Electricity production(% of total) of Fragile and conflict affected situations in 2008 and the Electricity production(% of total) of South Africa in 2011?
Your answer should be very brief. 14.55. What is the difference between the Electricity production(% of total) of Fragile and conflict affected situations in 2008 and the Electricity production(% of total) of Sudan in 2011?
Offer a very short reply. -61.14. What is the difference between the Electricity production(% of total) in Cambodia in 2008 and the Electricity production(% of total) in South Africa in 2011?
Provide a short and direct response. 2.11. What is the difference between the Electricity production(% of total) in Cambodia in 2008 and the Electricity production(% of total) in Sudan in 2011?
Give a very brief answer. -73.58. What is the difference between the Electricity production(% of total) in South Africa in 2008 and the Electricity production(% of total) in Sudan in 2011?
Your answer should be compact. -76.02. What is the difference between the Electricity production(% of total) in Fragile and conflict affected situations in 2009 and the Electricity production(% of total) in Cambodia in 2010?
Your response must be concise. 13.23. What is the difference between the Electricity production(% of total) in Fragile and conflict affected situations in 2009 and the Electricity production(% of total) in South Africa in 2010?
Ensure brevity in your answer.  15.02. What is the difference between the Electricity production(% of total) of Fragile and conflict affected situations in 2009 and the Electricity production(% of total) of Sudan in 2010?
Provide a short and direct response. -66.86. What is the difference between the Electricity production(% of total) in Cambodia in 2009 and the Electricity production(% of total) in South Africa in 2010?
Your answer should be compact. 2.12. What is the difference between the Electricity production(% of total) of Cambodia in 2009 and the Electricity production(% of total) of Sudan in 2010?
Provide a succinct answer. -79.76. What is the difference between the Electricity production(% of total) of South Africa in 2009 and the Electricity production(% of total) of Sudan in 2010?
Provide a succinct answer. -82.14. What is the difference between the Electricity production(% of total) of Fragile and conflict affected situations in 2009 and the Electricity production(% of total) of Cambodia in 2011?
Your response must be concise. 11.57. What is the difference between the Electricity production(% of total) of Fragile and conflict affected situations in 2009 and the Electricity production(% of total) of South Africa in 2011?
Give a very brief answer. 15.05. What is the difference between the Electricity production(% of total) of Fragile and conflict affected situations in 2009 and the Electricity production(% of total) of Sudan in 2011?
Offer a terse response. -60.64. What is the difference between the Electricity production(% of total) of Cambodia in 2009 and the Electricity production(% of total) of South Africa in 2011?
Provide a succinct answer. 2.15. What is the difference between the Electricity production(% of total) in Cambodia in 2009 and the Electricity production(% of total) in Sudan in 2011?
Provide a succinct answer. -73.54. What is the difference between the Electricity production(% of total) in South Africa in 2009 and the Electricity production(% of total) in Sudan in 2011?
Offer a very short reply. -75.92. What is the difference between the Electricity production(% of total) in Fragile and conflict affected situations in 2010 and the Electricity production(% of total) in Cambodia in 2011?
Your answer should be compact. 13.12. What is the difference between the Electricity production(% of total) in Fragile and conflict affected situations in 2010 and the Electricity production(% of total) in South Africa in 2011?
Offer a very short reply. 16.6. What is the difference between the Electricity production(% of total) of Fragile and conflict affected situations in 2010 and the Electricity production(% of total) of Sudan in 2011?
Keep it short and to the point. -59.1. What is the difference between the Electricity production(% of total) in Cambodia in 2010 and the Electricity production(% of total) in South Africa in 2011?
Offer a terse response. 1.82. What is the difference between the Electricity production(% of total) in Cambodia in 2010 and the Electricity production(% of total) in Sudan in 2011?
Offer a very short reply. -73.87. What is the difference between the Electricity production(% of total) in South Africa in 2010 and the Electricity production(% of total) in Sudan in 2011?
Keep it short and to the point. -75.66. What is the average Electricity production(% of total) in Fragile and conflict affected situations per year?
Make the answer very short. 17.4. What is the average Electricity production(% of total) of Cambodia per year?
Offer a very short reply. 3.48. What is the average Electricity production(% of total) in South Africa per year?
Provide a short and direct response. 0.64. What is the average Electricity production(% of total) of Sudan per year?
Provide a short and direct response. 44.95. In the year 2004, what is the difference between the Electricity production(% of total) of Fragile and conflict affected situations and Electricity production(% of total) of Cambodia?
Make the answer very short. 13.83. In the year 2004, what is the difference between the Electricity production(% of total) in Fragile and conflict affected situations and Electricity production(% of total) in South Africa?
Provide a short and direct response. 16.75. In the year 2004, what is the difference between the Electricity production(% of total) of Fragile and conflict affected situations and Electricity production(% of total) of Sudan?
Offer a very short reply. -14.78. In the year 2004, what is the difference between the Electricity production(% of total) in Cambodia and Electricity production(% of total) in South Africa?
Offer a terse response. 2.92. In the year 2004, what is the difference between the Electricity production(% of total) in Cambodia and Electricity production(% of total) in Sudan?
Provide a succinct answer. -28.61. In the year 2004, what is the difference between the Electricity production(% of total) in South Africa and Electricity production(% of total) in Sudan?
Ensure brevity in your answer.  -31.54. In the year 2005, what is the difference between the Electricity production(% of total) of Fragile and conflict affected situations and Electricity production(% of total) of Cambodia?
Provide a short and direct response. 15.23. In the year 2005, what is the difference between the Electricity production(% of total) in Fragile and conflict affected situations and Electricity production(% of total) in South Africa?
Ensure brevity in your answer.  19.24. In the year 2005, what is the difference between the Electricity production(% of total) in Fragile and conflict affected situations and Electricity production(% of total) in Sudan?
Offer a terse response. -13.17. In the year 2005, what is the difference between the Electricity production(% of total) of Cambodia and Electricity production(% of total) of South Africa?
Make the answer very short. 4.01. In the year 2005, what is the difference between the Electricity production(% of total) in Cambodia and Electricity production(% of total) in Sudan?
Your answer should be very brief. -28.39. In the year 2005, what is the difference between the Electricity production(% of total) of South Africa and Electricity production(% of total) of Sudan?
Offer a very short reply. -32.41. In the year 2006, what is the difference between the Electricity production(% of total) in Fragile and conflict affected situations and Electricity production(% of total) in Cambodia?
Provide a succinct answer. 14.89. In the year 2006, what is the difference between the Electricity production(% of total) in Fragile and conflict affected situations and Electricity production(% of total) in South Africa?
Your answer should be compact. 17.82. In the year 2006, what is the difference between the Electricity production(% of total) of Fragile and conflict affected situations and Electricity production(% of total) of Sudan?
Your response must be concise. -11.33. In the year 2006, what is the difference between the Electricity production(% of total) in Cambodia and Electricity production(% of total) in South Africa?
Provide a succinct answer. 2.93. In the year 2006, what is the difference between the Electricity production(% of total) in Cambodia and Electricity production(% of total) in Sudan?
Make the answer very short. -26.22. In the year 2006, what is the difference between the Electricity production(% of total) in South Africa and Electricity production(% of total) in Sudan?
Make the answer very short. -29.15. In the year 2007, what is the difference between the Electricity production(% of total) in Fragile and conflict affected situations and Electricity production(% of total) in Cambodia?
Your answer should be compact. 14.53. In the year 2007, what is the difference between the Electricity production(% of total) in Fragile and conflict affected situations and Electricity production(% of total) in South Africa?
Keep it short and to the point. 17.35. In the year 2007, what is the difference between the Electricity production(% of total) of Fragile and conflict affected situations and Electricity production(% of total) of Sudan?
Make the answer very short. -11.21. In the year 2007, what is the difference between the Electricity production(% of total) of Cambodia and Electricity production(% of total) of South Africa?
Offer a terse response. 2.82. In the year 2007, what is the difference between the Electricity production(% of total) of Cambodia and Electricity production(% of total) of Sudan?
Your answer should be compact. -25.74. In the year 2007, what is the difference between the Electricity production(% of total) of South Africa and Electricity production(% of total) of Sudan?
Your response must be concise. -28.57. In the year 2008, what is the difference between the Electricity production(% of total) of Fragile and conflict affected situations and Electricity production(% of total) of Cambodia?
Provide a succinct answer. 12.44. In the year 2008, what is the difference between the Electricity production(% of total) in Fragile and conflict affected situations and Electricity production(% of total) in South Africa?
Make the answer very short. 14.87. In the year 2008, what is the difference between the Electricity production(% of total) of Fragile and conflict affected situations and Electricity production(% of total) of Sudan?
Provide a succinct answer. -11.23. In the year 2008, what is the difference between the Electricity production(% of total) in Cambodia and Electricity production(% of total) in South Africa?
Give a very brief answer. 2.44. In the year 2008, what is the difference between the Electricity production(% of total) of Cambodia and Electricity production(% of total) of Sudan?
Your answer should be compact. -23.66. In the year 2008, what is the difference between the Electricity production(% of total) in South Africa and Electricity production(% of total) in Sudan?
Give a very brief answer. -26.1. In the year 2009, what is the difference between the Electricity production(% of total) in Fragile and conflict affected situations and Electricity production(% of total) in Cambodia?
Offer a terse response. 12.9. In the year 2009, what is the difference between the Electricity production(% of total) of Fragile and conflict affected situations and Electricity production(% of total) of South Africa?
Keep it short and to the point. 15.28. In the year 2009, what is the difference between the Electricity production(% of total) in Fragile and conflict affected situations and Electricity production(% of total) in Sudan?
Provide a succinct answer. -33.88. In the year 2009, what is the difference between the Electricity production(% of total) of Cambodia and Electricity production(% of total) of South Africa?
Offer a very short reply. 2.38. In the year 2009, what is the difference between the Electricity production(% of total) of Cambodia and Electricity production(% of total) of Sudan?
Your response must be concise. -46.78. In the year 2009, what is the difference between the Electricity production(% of total) of South Africa and Electricity production(% of total) of Sudan?
Your answer should be compact. -49.16. In the year 2010, what is the difference between the Electricity production(% of total) in Fragile and conflict affected situations and Electricity production(% of total) in Cambodia?
Make the answer very short. 14.77. In the year 2010, what is the difference between the Electricity production(% of total) in Fragile and conflict affected situations and Electricity production(% of total) in South Africa?
Make the answer very short. 16.56. In the year 2010, what is the difference between the Electricity production(% of total) of Fragile and conflict affected situations and Electricity production(% of total) of Sudan?
Offer a very short reply. -65.32. In the year 2010, what is the difference between the Electricity production(% of total) in Cambodia and Electricity production(% of total) in South Africa?
Offer a very short reply. 1.79. In the year 2010, what is the difference between the Electricity production(% of total) of Cambodia and Electricity production(% of total) of Sudan?
Your response must be concise. -80.09. In the year 2010, what is the difference between the Electricity production(% of total) in South Africa and Electricity production(% of total) in Sudan?
Give a very brief answer. -81.88. In the year 2011, what is the difference between the Electricity production(% of total) of Fragile and conflict affected situations and Electricity production(% of total) of Cambodia?
Provide a short and direct response. 12.79. In the year 2011, what is the difference between the Electricity production(% of total) of Fragile and conflict affected situations and Electricity production(% of total) of South Africa?
Provide a short and direct response. 16.27. In the year 2011, what is the difference between the Electricity production(% of total) of Fragile and conflict affected situations and Electricity production(% of total) of Sudan?
Provide a short and direct response. -59.43. In the year 2011, what is the difference between the Electricity production(% of total) of Cambodia and Electricity production(% of total) of South Africa?
Offer a very short reply. 3.48. In the year 2011, what is the difference between the Electricity production(% of total) of Cambodia and Electricity production(% of total) of Sudan?
Make the answer very short. -72.21. In the year 2011, what is the difference between the Electricity production(% of total) of South Africa and Electricity production(% of total) of Sudan?
Your answer should be compact. -75.69. What is the ratio of the Electricity production(% of total) in Fragile and conflict affected situations in 2004 to that in 2005?
Offer a terse response. 0.87. What is the ratio of the Electricity production(% of total) in Cambodia in 2004 to that in 2005?
Offer a very short reply. 0.73. What is the ratio of the Electricity production(% of total) in South Africa in 2004 to that in 2005?
Offer a very short reply. 0.72. What is the ratio of the Electricity production(% of total) of Sudan in 2004 to that in 2005?
Make the answer very short. 0.97. What is the ratio of the Electricity production(% of total) of Fragile and conflict affected situations in 2004 to that in 2006?
Provide a short and direct response. 0.9. What is the ratio of the Electricity production(% of total) of Cambodia in 2004 to that in 2006?
Offer a terse response. 0.81. What is the ratio of the Electricity production(% of total) of South Africa in 2004 to that in 2006?
Make the answer very short. 0.34. What is the ratio of the Electricity production(% of total) in Sudan in 2004 to that in 2006?
Keep it short and to the point. 1.05. What is the ratio of the Electricity production(% of total) of Fragile and conflict affected situations in 2004 to that in 2007?
Your response must be concise. 0.97. What is the ratio of the Electricity production(% of total) in Cambodia in 2004 to that in 2007?
Your answer should be very brief. 1.05. What is the ratio of the Electricity production(% of total) of South Africa in 2004 to that in 2007?
Your response must be concise. 1.18. What is the ratio of the Electricity production(% of total) of Sudan in 2004 to that in 2007?
Your response must be concise. 1.1. What is the ratio of the Electricity production(% of total) of Fragile and conflict affected situations in 2004 to that in 2008?
Provide a succinct answer. 1.12. What is the ratio of the Electricity production(% of total) of Cambodia in 2004 to that in 2008?
Offer a very short reply. 1.14. What is the ratio of the Electricity production(% of total) of South Africa in 2004 to that in 2008?
Offer a terse response. 0.84. What is the ratio of the Electricity production(% of total) of Sudan in 2004 to that in 2008?
Offer a very short reply. 1.2. What is the ratio of the Electricity production(% of total) in Fragile and conflict affected situations in 2004 to that in 2009?
Ensure brevity in your answer.  1.08. What is the ratio of the Electricity production(% of total) of Cambodia in 2004 to that in 2009?
Make the answer very short. 1.13. What is the ratio of the Electricity production(% of total) in South Africa in 2004 to that in 2009?
Keep it short and to the point. 0.7. What is the ratio of the Electricity production(% of total) of Sudan in 2004 to that in 2009?
Offer a terse response. 0.64. What is the ratio of the Electricity production(% of total) in Fragile and conflict affected situations in 2004 to that in 2010?
Give a very brief answer. 0.99. What is the ratio of the Electricity production(% of total) in Cambodia in 2004 to that in 2010?
Provide a succinct answer. 1.27. What is the ratio of the Electricity production(% of total) of South Africa in 2004 to that in 2010?
Offer a terse response. 0.48. What is the ratio of the Electricity production(% of total) of Sudan in 2004 to that in 2010?
Offer a terse response. 0.39. What is the ratio of the Electricity production(% of total) of Cambodia in 2004 to that in 2011?
Give a very brief answer. 0.78. What is the ratio of the Electricity production(% of total) in South Africa in 2004 to that in 2011?
Keep it short and to the point. 0.5. What is the ratio of the Electricity production(% of total) of Sudan in 2004 to that in 2011?
Ensure brevity in your answer.  0.42. What is the ratio of the Electricity production(% of total) in Fragile and conflict affected situations in 2005 to that in 2006?
Offer a terse response. 1.04. What is the ratio of the Electricity production(% of total) of Cambodia in 2005 to that in 2006?
Make the answer very short. 1.12. What is the ratio of the Electricity production(% of total) in South Africa in 2005 to that in 2006?
Keep it short and to the point. 0.48. What is the ratio of the Electricity production(% of total) in Sudan in 2005 to that in 2006?
Your response must be concise. 1.09. What is the ratio of the Electricity production(% of total) of Fragile and conflict affected situations in 2005 to that in 2007?
Give a very brief answer. 1.12. What is the ratio of the Electricity production(% of total) in Cambodia in 2005 to that in 2007?
Your answer should be very brief. 1.45. What is the ratio of the Electricity production(% of total) in South Africa in 2005 to that in 2007?
Keep it short and to the point. 1.65. What is the ratio of the Electricity production(% of total) in Sudan in 2005 to that in 2007?
Your answer should be compact. 1.14. What is the ratio of the Electricity production(% of total) of Fragile and conflict affected situations in 2005 to that in 2008?
Ensure brevity in your answer.  1.29. What is the ratio of the Electricity production(% of total) in Cambodia in 2005 to that in 2008?
Make the answer very short. 1.57. What is the ratio of the Electricity production(% of total) in South Africa in 2005 to that in 2008?
Your response must be concise. 1.17. What is the ratio of the Electricity production(% of total) in Sudan in 2005 to that in 2008?
Your response must be concise. 1.24. What is the ratio of the Electricity production(% of total) in Fragile and conflict affected situations in 2005 to that in 2009?
Ensure brevity in your answer.  1.25. What is the ratio of the Electricity production(% of total) of Cambodia in 2005 to that in 2009?
Your answer should be compact. 1.55. What is the ratio of the Electricity production(% of total) of South Africa in 2005 to that in 2009?
Provide a short and direct response. 0.97. What is the ratio of the Electricity production(% of total) of Sudan in 2005 to that in 2009?
Ensure brevity in your answer.  0.66. What is the ratio of the Electricity production(% of total) in Fragile and conflict affected situations in 2005 to that in 2010?
Your answer should be very brief. 1.14. What is the ratio of the Electricity production(% of total) in Cambodia in 2005 to that in 2010?
Your response must be concise. 1.75. What is the ratio of the Electricity production(% of total) of South Africa in 2005 to that in 2010?
Offer a very short reply. 0.67. What is the ratio of the Electricity production(% of total) in Sudan in 2005 to that in 2010?
Your answer should be compact. 0.4. What is the ratio of the Electricity production(% of total) of Fragile and conflict affected situations in 2005 to that in 2011?
Provide a short and direct response. 1.16. What is the ratio of the Electricity production(% of total) of Cambodia in 2005 to that in 2011?
Your answer should be compact. 1.07. What is the ratio of the Electricity production(% of total) in South Africa in 2005 to that in 2011?
Provide a short and direct response. 0.69. What is the ratio of the Electricity production(% of total) in Sudan in 2005 to that in 2011?
Ensure brevity in your answer.  0.43. What is the ratio of the Electricity production(% of total) of Fragile and conflict affected situations in 2006 to that in 2007?
Ensure brevity in your answer.  1.07. What is the ratio of the Electricity production(% of total) in Cambodia in 2006 to that in 2007?
Keep it short and to the point. 1.29. What is the ratio of the Electricity production(% of total) of South Africa in 2006 to that in 2007?
Your answer should be compact. 3.47. What is the ratio of the Electricity production(% of total) of Sudan in 2006 to that in 2007?
Provide a succinct answer. 1.05. What is the ratio of the Electricity production(% of total) of Fragile and conflict affected situations in 2006 to that in 2008?
Offer a very short reply. 1.24. What is the ratio of the Electricity production(% of total) in Cambodia in 2006 to that in 2008?
Your response must be concise. 1.4. What is the ratio of the Electricity production(% of total) in South Africa in 2006 to that in 2008?
Your answer should be compact. 2.45. What is the ratio of the Electricity production(% of total) in Sudan in 2006 to that in 2008?
Provide a short and direct response. 1.14. What is the ratio of the Electricity production(% of total) of Fragile and conflict affected situations in 2006 to that in 2009?
Offer a terse response. 1.2. What is the ratio of the Electricity production(% of total) of Cambodia in 2006 to that in 2009?
Provide a short and direct response. 1.39. What is the ratio of the Electricity production(% of total) of South Africa in 2006 to that in 2009?
Your answer should be compact. 2.04. What is the ratio of the Electricity production(% of total) in Sudan in 2006 to that in 2009?
Offer a terse response. 0.61. What is the ratio of the Electricity production(% of total) of Fragile and conflict affected situations in 2006 to that in 2010?
Ensure brevity in your answer.  1.09. What is the ratio of the Electricity production(% of total) of Cambodia in 2006 to that in 2010?
Your answer should be compact. 1.56. What is the ratio of the Electricity production(% of total) of South Africa in 2006 to that in 2010?
Offer a very short reply. 1.4. What is the ratio of the Electricity production(% of total) in Sudan in 2006 to that in 2010?
Provide a short and direct response. 0.37. What is the ratio of the Electricity production(% of total) of Fragile and conflict affected situations in 2006 to that in 2011?
Offer a very short reply. 1.11. What is the ratio of the Electricity production(% of total) of Cambodia in 2006 to that in 2011?
Ensure brevity in your answer.  0.96. What is the ratio of the Electricity production(% of total) in South Africa in 2006 to that in 2011?
Provide a succinct answer. 1.46. What is the ratio of the Electricity production(% of total) of Sudan in 2006 to that in 2011?
Ensure brevity in your answer.  0.4. What is the ratio of the Electricity production(% of total) in Fragile and conflict affected situations in 2007 to that in 2008?
Keep it short and to the point. 1.15. What is the ratio of the Electricity production(% of total) in Cambodia in 2007 to that in 2008?
Your answer should be very brief. 1.09. What is the ratio of the Electricity production(% of total) of South Africa in 2007 to that in 2008?
Make the answer very short. 0.71. What is the ratio of the Electricity production(% of total) of Sudan in 2007 to that in 2008?
Provide a succinct answer. 1.09. What is the ratio of the Electricity production(% of total) in Fragile and conflict affected situations in 2007 to that in 2009?
Your response must be concise. 1.12. What is the ratio of the Electricity production(% of total) in Cambodia in 2007 to that in 2009?
Keep it short and to the point. 1.07. What is the ratio of the Electricity production(% of total) in South Africa in 2007 to that in 2009?
Your response must be concise. 0.59. What is the ratio of the Electricity production(% of total) in Sudan in 2007 to that in 2009?
Your response must be concise. 0.58. What is the ratio of the Electricity production(% of total) of Fragile and conflict affected situations in 2007 to that in 2010?
Make the answer very short. 1.02. What is the ratio of the Electricity production(% of total) in Cambodia in 2007 to that in 2010?
Provide a short and direct response. 1.21. What is the ratio of the Electricity production(% of total) in South Africa in 2007 to that in 2010?
Provide a succinct answer. 0.4. What is the ratio of the Electricity production(% of total) of Sudan in 2007 to that in 2010?
Keep it short and to the point. 0.35. What is the ratio of the Electricity production(% of total) of Fragile and conflict affected situations in 2007 to that in 2011?
Your answer should be compact. 1.04. What is the ratio of the Electricity production(% of total) in Cambodia in 2007 to that in 2011?
Keep it short and to the point. 0.74. What is the ratio of the Electricity production(% of total) in South Africa in 2007 to that in 2011?
Ensure brevity in your answer.  0.42. What is the ratio of the Electricity production(% of total) in Sudan in 2007 to that in 2011?
Make the answer very short. 0.38. What is the ratio of the Electricity production(% of total) of Fragile and conflict affected situations in 2008 to that in 2009?
Your response must be concise. 0.97. What is the ratio of the Electricity production(% of total) in Cambodia in 2008 to that in 2009?
Provide a succinct answer. 0.99. What is the ratio of the Electricity production(% of total) of South Africa in 2008 to that in 2009?
Your answer should be very brief. 0.83. What is the ratio of the Electricity production(% of total) in Sudan in 2008 to that in 2009?
Ensure brevity in your answer.  0.53. What is the ratio of the Electricity production(% of total) of Fragile and conflict affected situations in 2008 to that in 2010?
Offer a terse response. 0.88. What is the ratio of the Electricity production(% of total) of Cambodia in 2008 to that in 2010?
Your answer should be compact. 1.11. What is the ratio of the Electricity production(% of total) in South Africa in 2008 to that in 2010?
Provide a succinct answer. 0.57. What is the ratio of the Electricity production(% of total) of Sudan in 2008 to that in 2010?
Provide a succinct answer. 0.32. What is the ratio of the Electricity production(% of total) of Fragile and conflict affected situations in 2008 to that in 2011?
Provide a succinct answer. 0.9. What is the ratio of the Electricity production(% of total) in Cambodia in 2008 to that in 2011?
Your answer should be very brief. 0.68. What is the ratio of the Electricity production(% of total) of South Africa in 2008 to that in 2011?
Your response must be concise. 0.59. What is the ratio of the Electricity production(% of total) in Sudan in 2008 to that in 2011?
Make the answer very short. 0.35. What is the ratio of the Electricity production(% of total) of Fragile and conflict affected situations in 2009 to that in 2010?
Your response must be concise. 0.91. What is the ratio of the Electricity production(% of total) of Cambodia in 2009 to that in 2010?
Keep it short and to the point. 1.13. What is the ratio of the Electricity production(% of total) in South Africa in 2009 to that in 2010?
Provide a succinct answer. 0.69. What is the ratio of the Electricity production(% of total) of Sudan in 2009 to that in 2010?
Provide a short and direct response. 0.6. What is the ratio of the Electricity production(% of total) of Fragile and conflict affected situations in 2009 to that in 2011?
Provide a short and direct response. 0.93. What is the ratio of the Electricity production(% of total) of Cambodia in 2009 to that in 2011?
Give a very brief answer. 0.69. What is the ratio of the Electricity production(% of total) of South Africa in 2009 to that in 2011?
Give a very brief answer. 0.72. What is the ratio of the Electricity production(% of total) of Sudan in 2009 to that in 2011?
Provide a succinct answer. 0.65. What is the ratio of the Electricity production(% of total) of Fragile and conflict affected situations in 2010 to that in 2011?
Your answer should be compact. 1.02. What is the ratio of the Electricity production(% of total) in Cambodia in 2010 to that in 2011?
Your answer should be very brief. 0.61. What is the ratio of the Electricity production(% of total) of South Africa in 2010 to that in 2011?
Your answer should be very brief. 1.04. What is the ratio of the Electricity production(% of total) of Sudan in 2010 to that in 2011?
Ensure brevity in your answer.  1.08. What is the difference between the highest and the second highest Electricity production(% of total) of Fragile and conflict affected situations?
Your answer should be very brief. 0.82. What is the difference between the highest and the second highest Electricity production(% of total) of Cambodia?
Make the answer very short. 0.29. What is the difference between the highest and the second highest Electricity production(% of total) of South Africa?
Offer a terse response. 0.33. What is the difference between the highest and the second highest Electricity production(% of total) of Sudan?
Your response must be concise. 6.22. What is the difference between the highest and the lowest Electricity production(% of total) in Fragile and conflict affected situations?
Provide a short and direct response. 4.45. What is the difference between the highest and the lowest Electricity production(% of total) in Cambodia?
Make the answer very short. 1.95. What is the difference between the highest and the lowest Electricity production(% of total) of South Africa?
Give a very brief answer. 0.82. What is the difference between the highest and the lowest Electricity production(% of total) of Sudan?
Your answer should be very brief. 56.13. 